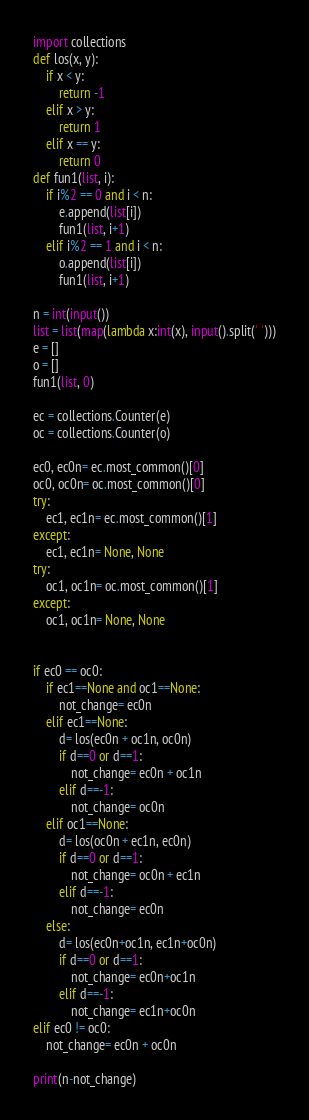<code> <loc_0><loc_0><loc_500><loc_500><_Python_>import collections
def los(x, y):
    if x < y:
        return -1
    elif x > y:
        return 1
    elif x == y:
        return 0
def fun1(list, i):
    if i%2 == 0 and i < n:
        e.append(list[i])
        fun1(list, i+1)
    elif i%2 == 1 and i < n:
        o.append(list[i])
        fun1(list, i+1)

n = int(input())
list = list(map(lambda x:int(x), input().split(' ')))
e = []
o = []
fun1(list, 0)

ec = collections.Counter(e)
oc = collections.Counter(o)

ec0, ec0n= ec.most_common()[0]
oc0, oc0n= oc.most_common()[0]
try:
    ec1, ec1n= ec.most_common()[1]
except:
    ec1, ec1n= None, None
try:
    oc1, oc1n= oc.most_common()[1]
except:
    oc1, oc1n= None, None


if ec0 == oc0:
    if ec1==None and oc1==None:
        not_change= ec0n
    elif ec1==None:
        d= los(ec0n + oc1n, oc0n)
        if d==0 or d==1:
            not_change= ec0n + oc1n
        elif d==-1:
            not_change= oc0n
    elif oc1==None:
        d= los(oc0n + ec1n, ec0n)
        if d==0 or d==1:
            not_change= oc0n + ec1n
        elif d==-1:
            not_change= ec0n
    else:
        d= los(ec0n+oc1n, ec1n+oc0n)
        if d==0 or d==1:
            not_change= ec0n+oc1n
        elif d==-1:
            not_change= ec1n+oc0n
elif ec0 != oc0:
    not_change= ec0n + oc0n

print(n-not_change)
</code> 